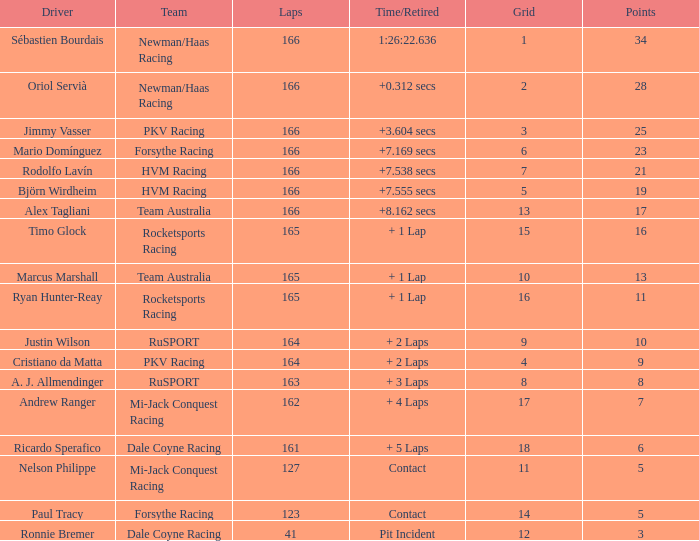What is the average points that the driver Ryan Hunter-Reay has? 11.0. 